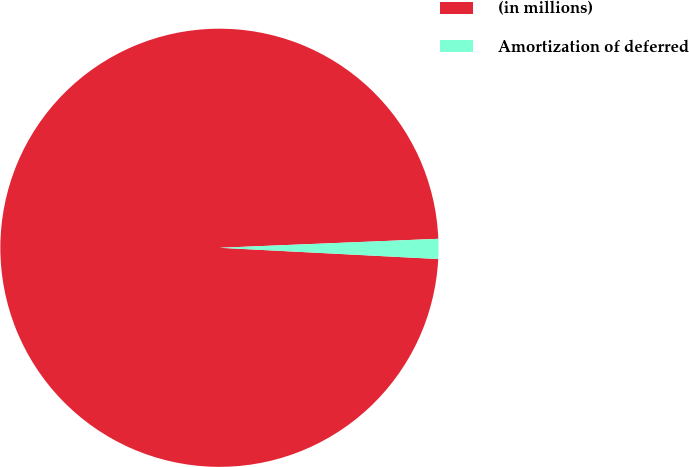Convert chart to OTSL. <chart><loc_0><loc_0><loc_500><loc_500><pie_chart><fcel>(in millions)<fcel>Amortization of deferred<nl><fcel>98.53%<fcel>1.47%<nl></chart> 